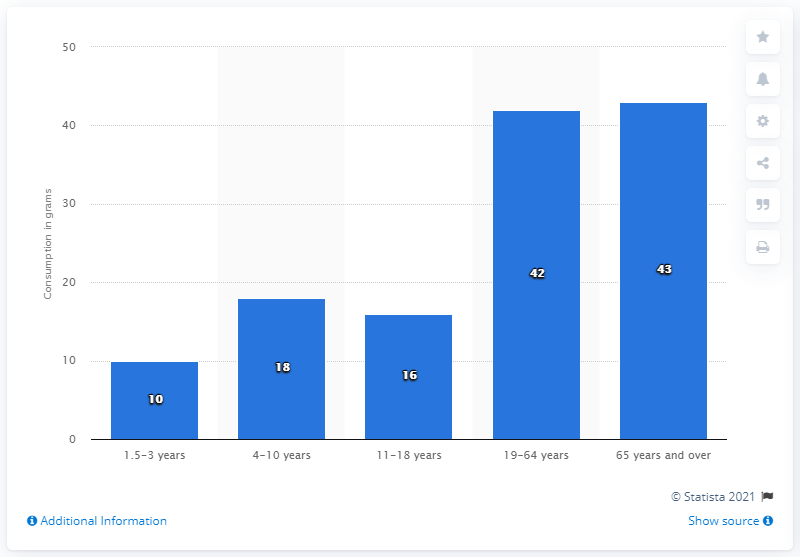Highlight a few significant elements in this photo. A study conducted between 2008 and 2012 found that individuals aged 65 years and over consumed an average of 43 grams of salad and raw vegetables per day. 